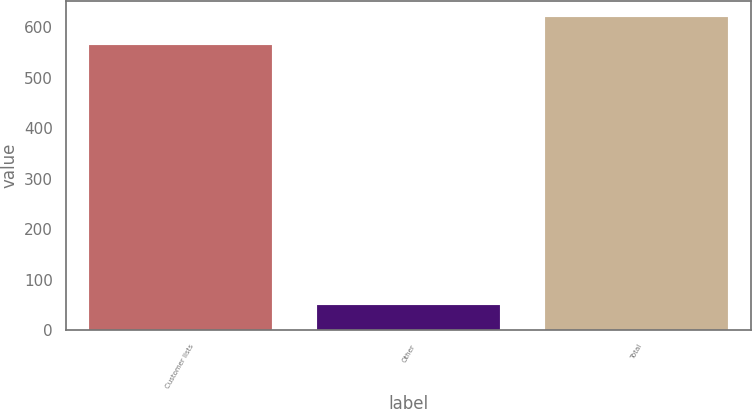Convert chart to OTSL. <chart><loc_0><loc_0><loc_500><loc_500><bar_chart><fcel>Customer lists<fcel>Other<fcel>Total<nl><fcel>564<fcel>50<fcel>620.4<nl></chart> 